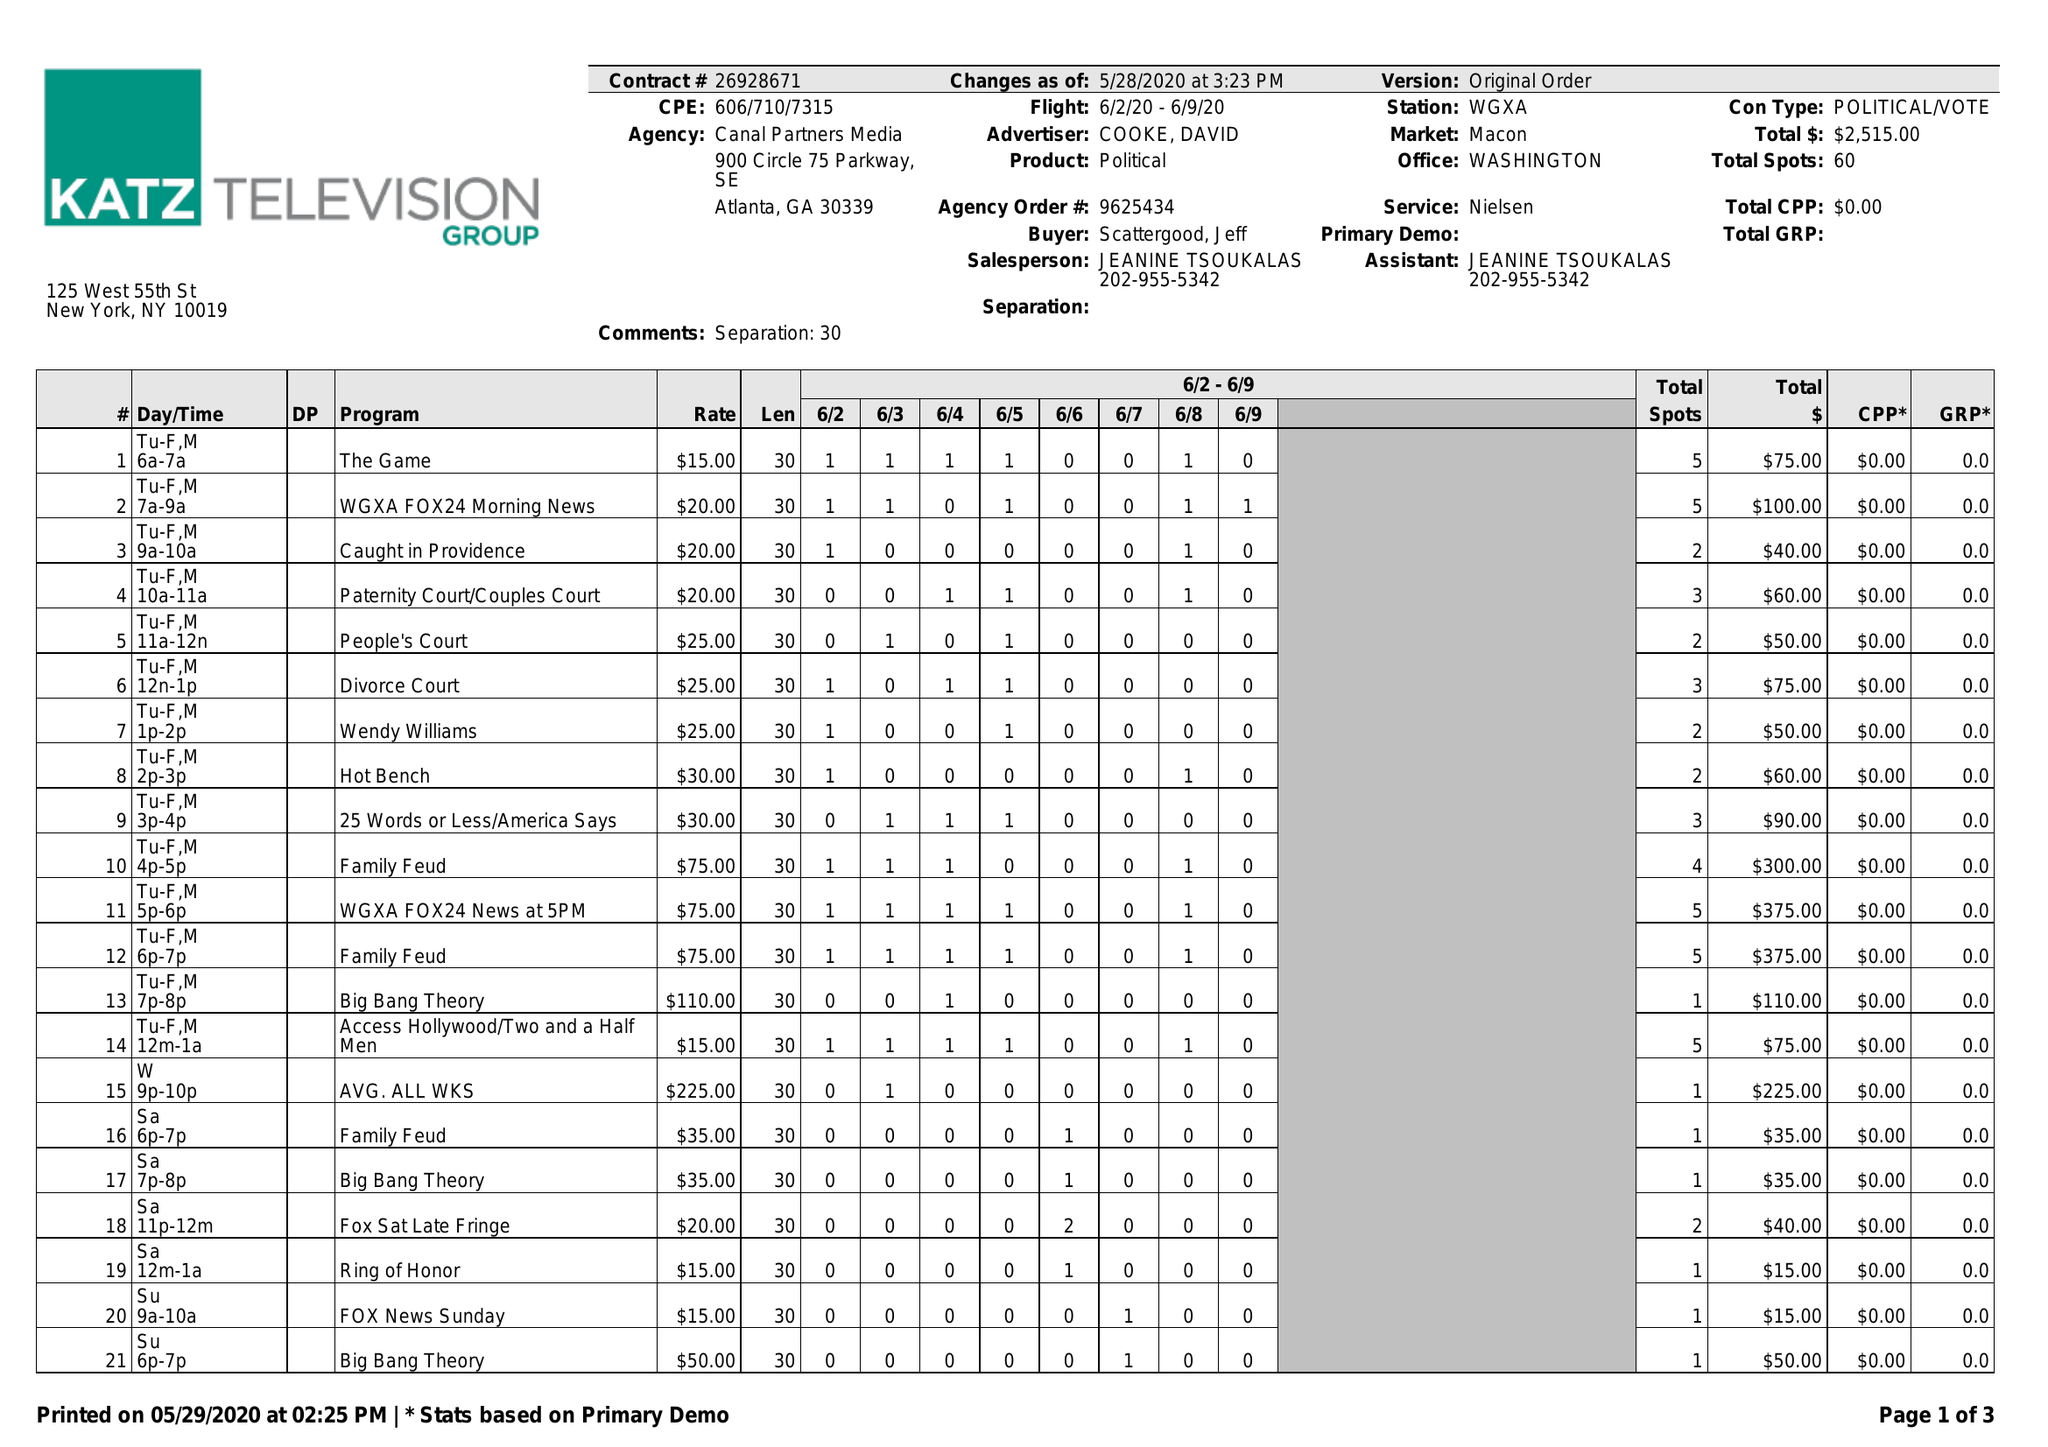What is the value for the flight_from?
Answer the question using a single word or phrase. 06/02/20 